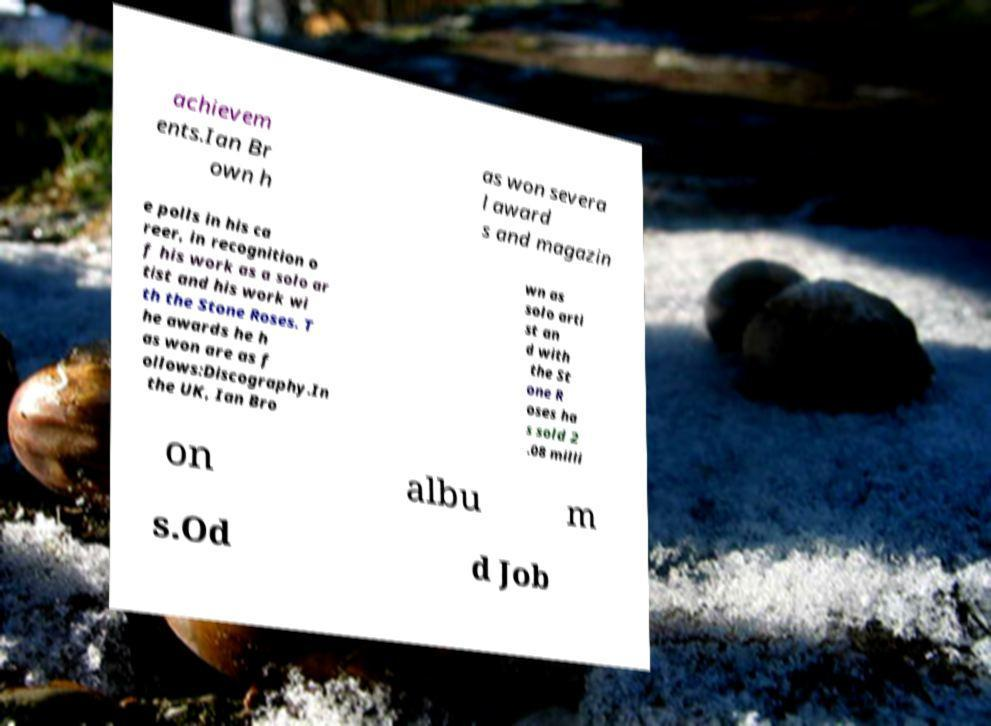What messages or text are displayed in this image? I need them in a readable, typed format. achievem ents.Ian Br own h as won severa l award s and magazin e polls in his ca reer, in recognition o f his work as a solo ar tist and his work wi th the Stone Roses. T he awards he h as won are as f ollows:Discography.In the UK, Ian Bro wn as solo arti st an d with the St one R oses ha s sold 2 .08 milli on albu m s.Od d Job 